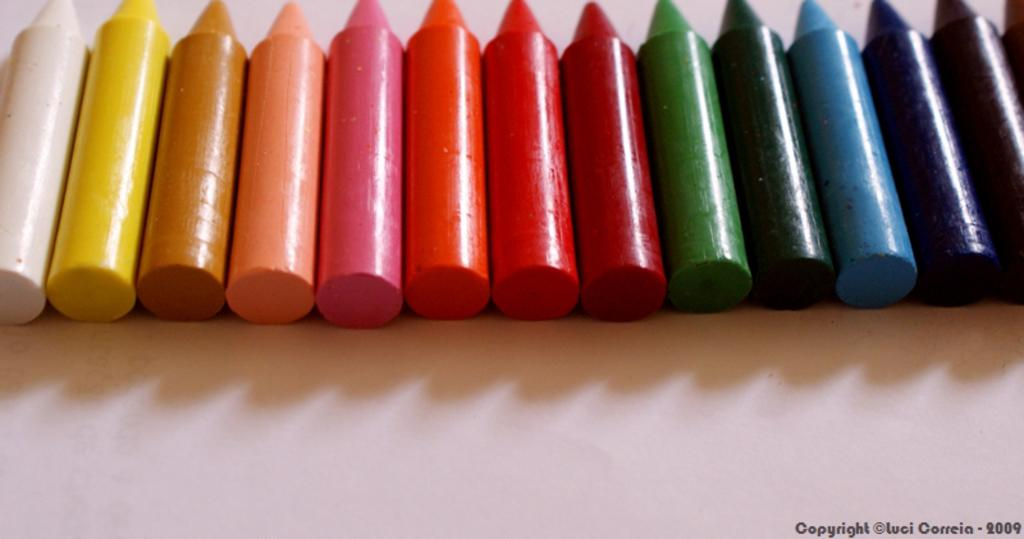What type of art supplies can be seen in the image? There are crayons in the image. What else is present on the right side of the image? There is text on the right side of the image. Is there a parcel being swung in the yard in the image? There is no mention of a parcel or a yard in the image, so it cannot be determined if there is a parcel being swung in the yard. 